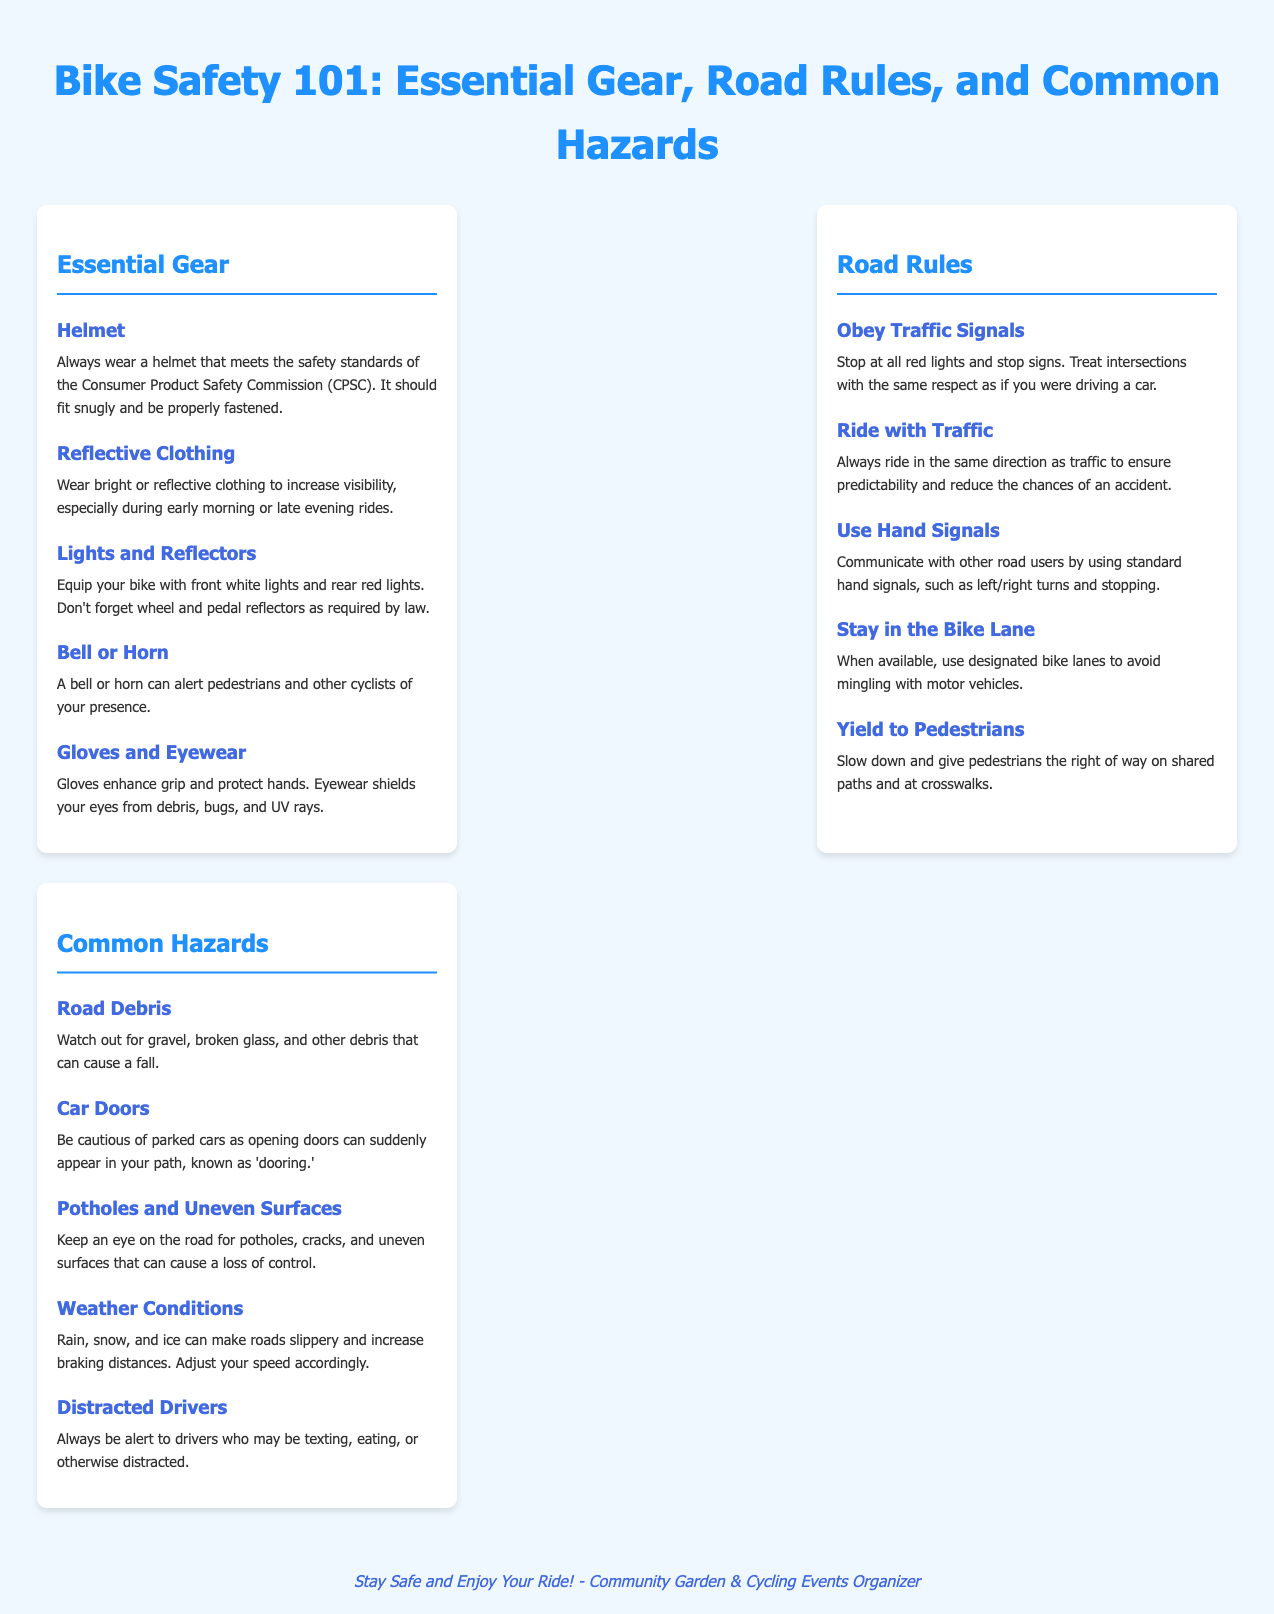What is the title of the document? The title of the document is displayed at the top and provides a clear subject for the content.
Answer: Bike Safety 101: Essential Gear, Road Rules, and Common Hazards What essential gear is recommended for cycling? The document lists several essential gear items for safe cycling, specifically in the Essential Gear section.
Answer: Helmet What is one way to increase visibility while cycling? The document advises wearing bright or reflective clothing to enhance visibility during rides.
Answer: Reflective Clothing What hand signal is suggested for stopping? The document indicates that cyclists should use hand signals to communicate with other road users, including a signal for stopping.
Answer: Hand Signals Which section includes hazards encountered while cycling? The sections of the document are categorized, making it easy to identify the section that deals with potential hazards.
Answer: Common Hazards What should cyclists do at red lights? The document emphasizes the importance of adhering to traffic signals for safety on the road.
Answer: Stop Name a common hazard mentioned in the document. The Common Hazards section provides a list of dangers cyclists might encounter on the road.
Answer: Road Debris What is one item cyclists should have for alerting others? The document suggests an item that can be used to make others aware of a cyclist's presence.
Answer: Bell or Horn How should cyclists ride in relation to traffic? The document provides guidance on the direction cyclists should ride in to ensure safety on the road.
Answer: With Traffic 